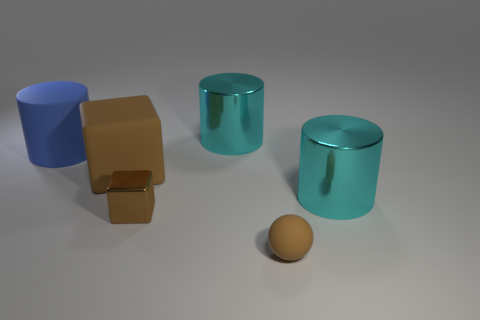Are there any other things that are the same shape as the small rubber object?
Offer a terse response. No. Do the large metal object that is behind the blue matte cylinder and the large shiny cylinder on the right side of the small matte ball have the same color?
Keep it short and to the point. Yes. What is the material of the blue cylinder to the left of the large cylinder that is in front of the thing that is left of the big brown cube?
Your response must be concise. Rubber. Are there any brown objects that have the same size as the blue matte cylinder?
Offer a very short reply. Yes. There is a block that is the same size as the sphere; what is its material?
Your response must be concise. Metal. What shape is the large cyan shiny thing that is behind the large matte cylinder?
Ensure brevity in your answer.  Cylinder. Are the cyan cylinder behind the large brown matte thing and the tiny brown thing that is on the left side of the small rubber object made of the same material?
Offer a very short reply. Yes. What number of large cyan shiny objects are the same shape as the blue rubber object?
Provide a succinct answer. 2. There is another small block that is the same color as the rubber block; what material is it?
Ensure brevity in your answer.  Metal. What number of objects are big blue objects or brown objects behind the tiny rubber ball?
Offer a terse response. 3. 